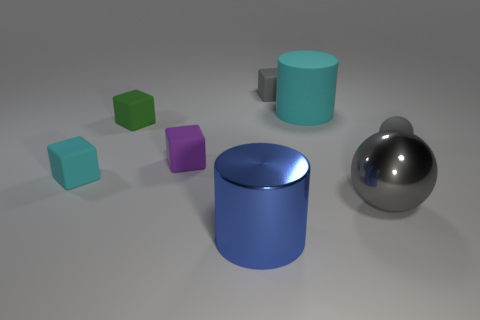Does the tiny rubber ball have the same color as the shiny ball?
Your answer should be compact. Yes. How many objects are gray things on the left side of the big cyan cylinder or rubber cubes on the left side of the tiny purple object?
Offer a terse response. 3. What number of objects are tiny cyan matte things or big objects?
Give a very brief answer. 4. There is a thing that is on the left side of the small purple rubber thing and in front of the purple rubber cube; how big is it?
Give a very brief answer. Small. How many big brown things are made of the same material as the small ball?
Make the answer very short. 0. There is another big thing that is the same material as the large gray thing; what color is it?
Give a very brief answer. Blue. There is a small thing that is on the right side of the large gray ball; is its color the same as the metal ball?
Give a very brief answer. Yes. There is a big cylinder that is behind the gray shiny object; what material is it?
Make the answer very short. Rubber. Is the number of big gray things that are to the left of the small purple block the same as the number of tiny gray cylinders?
Keep it short and to the point. Yes. What number of small things are the same color as the shiny sphere?
Provide a short and direct response. 2. 